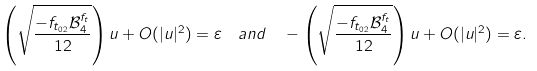<formula> <loc_0><loc_0><loc_500><loc_500>\left ( \sqrt { \frac { - f _ { t _ { 0 2 } } \mathcal { B } ^ { f _ { t } } _ { 4 } } { 1 2 } } \right ) u + O ( | u | ^ { 2 } ) & = \varepsilon \quad a n d \quad - \left ( \sqrt { \frac { - f _ { t _ { 0 2 } } \mathcal { B } ^ { f _ { t } } _ { 4 } } { 1 2 } } \right ) u + O ( | u | ^ { 2 } ) = \varepsilon .</formula> 